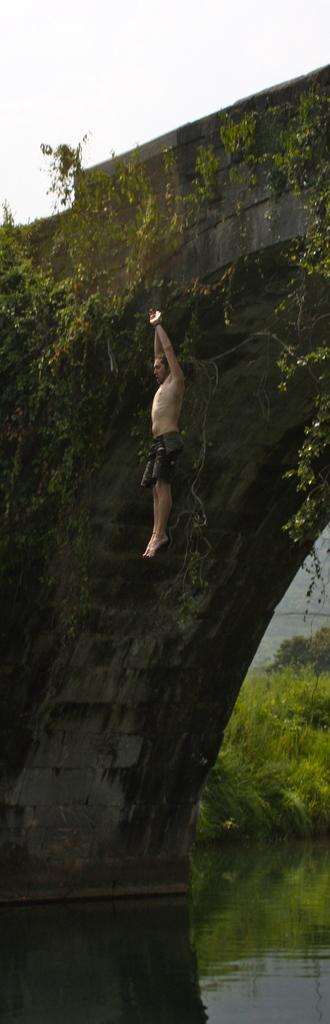Who is the main subject in the image? There is a person in the image. What is the person doing in the image? The person is jumping into the water. What can be seen at the bottom of the image? There is water visible at the bottom of the image. What type of vegetation is on the right side of the image? There are bushes on the right side of the image. What structure is visible at the top of the image? There is a bridge-like structure at the top of the image. What type of list can be seen on the person's hand in the image? There is no list visible on the person's hand in the image. How many oranges are being held by the person in the image? There are no oranges present in the image. 